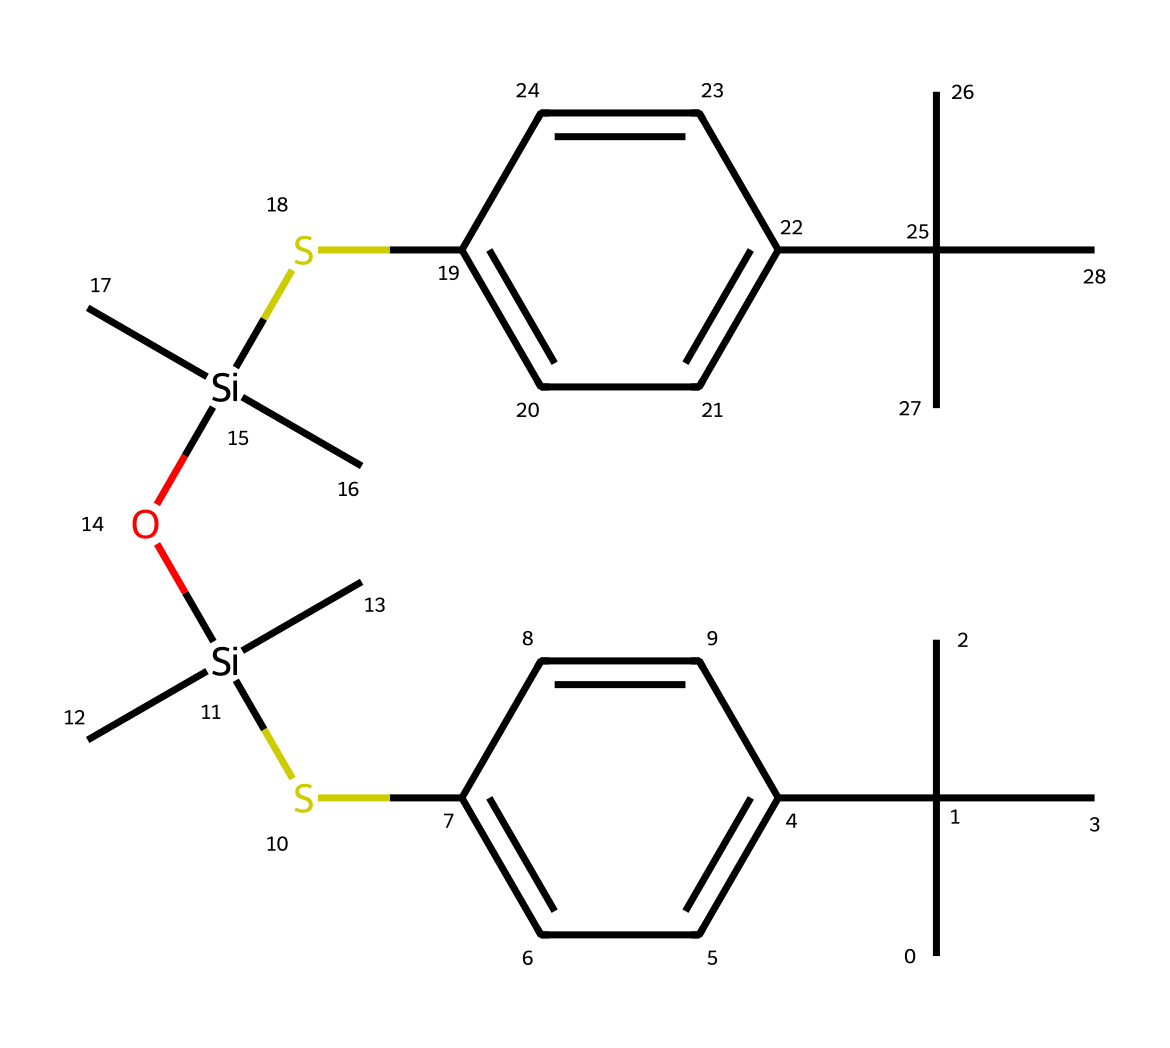What is the main functional group present in this polymer? The structure indicates the presence of siloxane (Si-O) linkages that define the polymer. These linkages contribute to the heat resistance and flexibility of the rubber.
Answer: siloxane How many silicon atoms are in this chemical structure? By analyzing the SMILES representation, we can count two silicon atoms connected by oxygen atoms, confirming their presence.
Answer: two What is the largest aromatic ring system present? The structure includes two aromatic rings, specifically biphenyl groups, which are a significant feature providing thermal stability and strength.
Answer: biphenyl What type of bonding primarily exists between the silicon and oxygen atoms? The bonding between silicon and oxygen atoms in this polymer is predominantly covalent. This contributes to the stability and heat resistance of the material overall.
Answer: covalent How many carbon atoms are present in the entire molecule? By counting the carbon atoms in the SMILES string, we find a total of 28 carbon atoms in the structure.
Answer: 28 